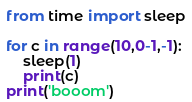Convert code to text. <code><loc_0><loc_0><loc_500><loc_500><_Python_>from time import sleep

for c in range(10,0-1,-1):
    sleep(1)
    print(c) 
print('booom')



</code> 